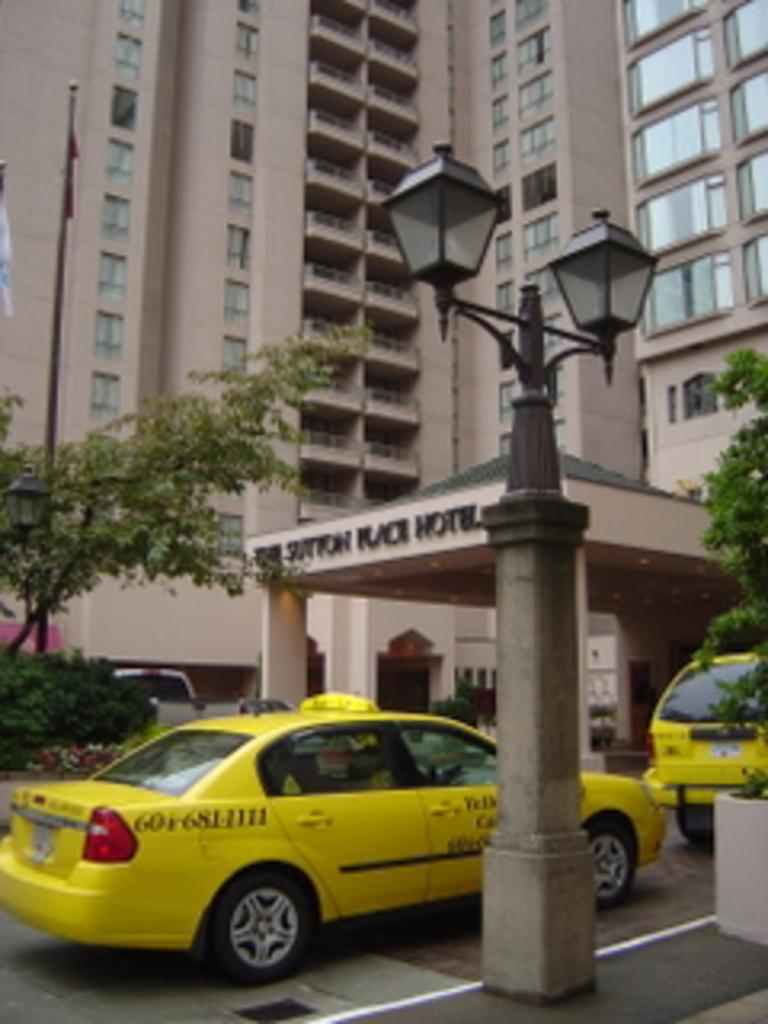<image>
Present a compact description of the photo's key features. A yellow car goes under a sign that has the word hotel on it 